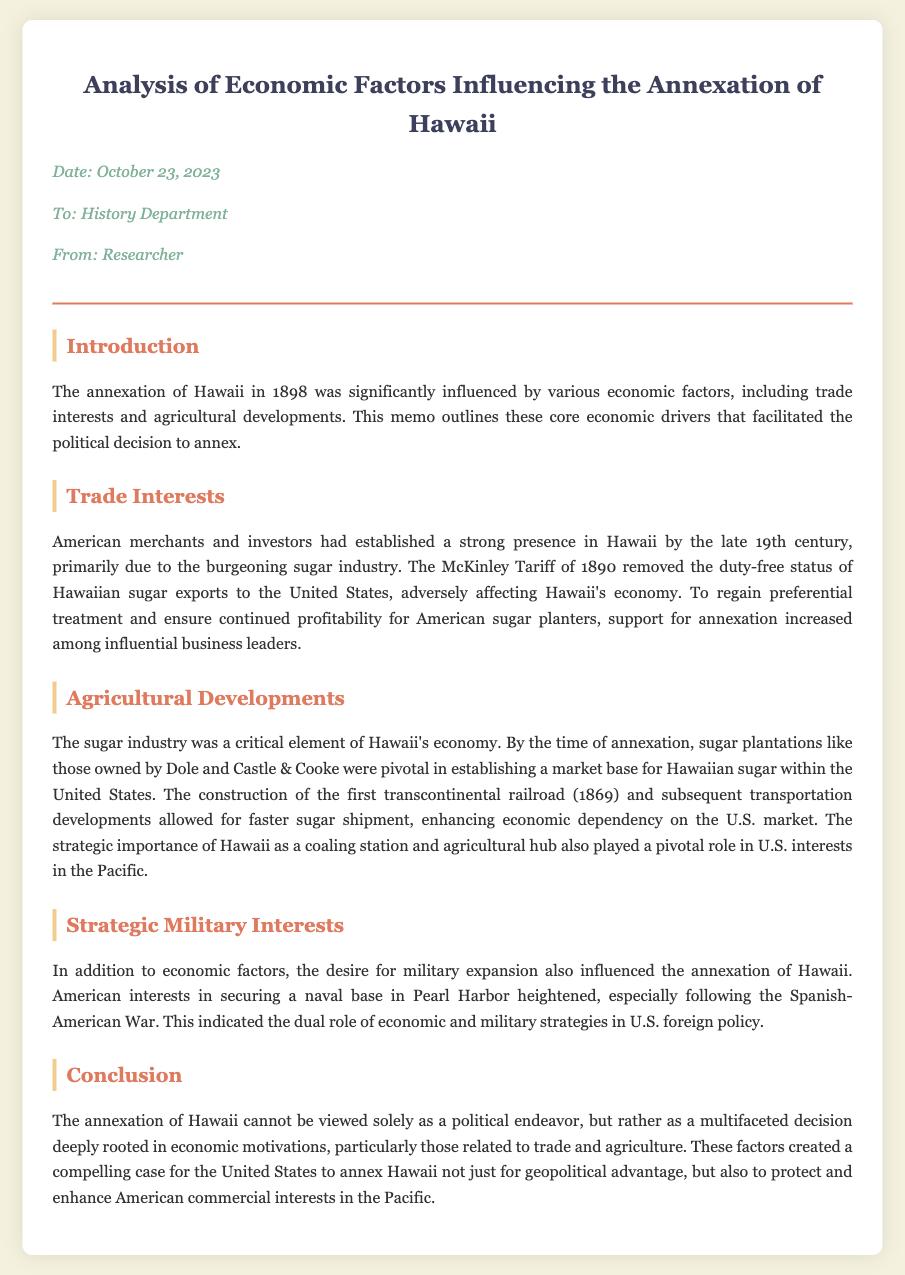What year did Hawaii get annexed? The document states that Hawaii was annexed in 1898.
Answer: 1898 Who were some major plantation owners mentioned? The memo mentions Dole and Castle & Cooke as pivotal plantation owners.
Answer: Dole and Castle & Cooke What tariff removed the duty-free status of Hawaiian sugar? The document refers to the McKinley Tariff of 1890.
Answer: McKinley Tariff What was a key agricultural product of Hawaii? The main agricultural product discussed in the memo is sugar.
Answer: Sugar Which important infrastructure was completed in 1869? The document notes the completion of the first transcontinental railroad in 1869.
Answer: First transcontinental railroad What major conflict increased U.S. military interest in Hawaii? The memo indicates that the Spanish-American War heightened military interest.
Answer: Spanish-American War What economic aspect created a compelling case for annexation? The document highlights trade and agricultural motivations as key economic aspects.
Answer: Trade and agricultural motivations What was the strategic military location mentioned in the document? The document specifies Pearl Harbor as a strategic military location.
Answer: Pearl Harbor 